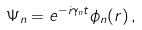Convert formula to latex. <formula><loc_0><loc_0><loc_500><loc_500>\Psi _ { n } = e ^ { - i \gamma _ { n } t } \phi _ { n } ( r ) \, ,</formula> 